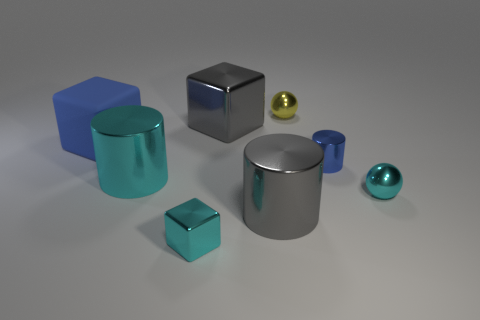There is a tiny yellow object that is made of the same material as the large cyan thing; what is its shape?
Provide a succinct answer. Sphere. Do the large gray thing that is behind the big cyan thing and the blue metal object have the same shape?
Your answer should be very brief. No. What is the shape of the gray metallic thing that is behind the small cyan sphere?
Ensure brevity in your answer.  Cube. The large rubber object that is the same color as the tiny metal cylinder is what shape?
Ensure brevity in your answer.  Cube. How many things are the same size as the yellow sphere?
Your response must be concise. 3. What color is the small metallic cylinder?
Your response must be concise. Blue. There is a rubber object; is its color the same as the metallic block that is behind the blue cube?
Offer a very short reply. No. The gray block that is made of the same material as the tiny cylinder is what size?
Provide a succinct answer. Large. Is there a tiny block of the same color as the big metal cube?
Your answer should be very brief. No. What number of objects are either big metallic objects that are to the right of the big rubber block or metal blocks?
Your response must be concise. 4. 